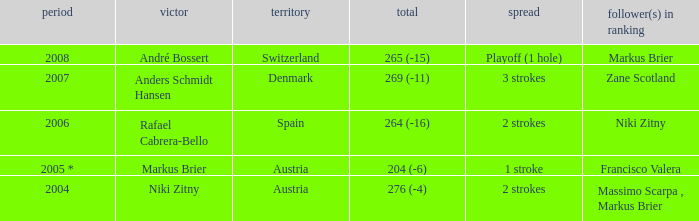What was the score in the year 2004? 276 (-4). 